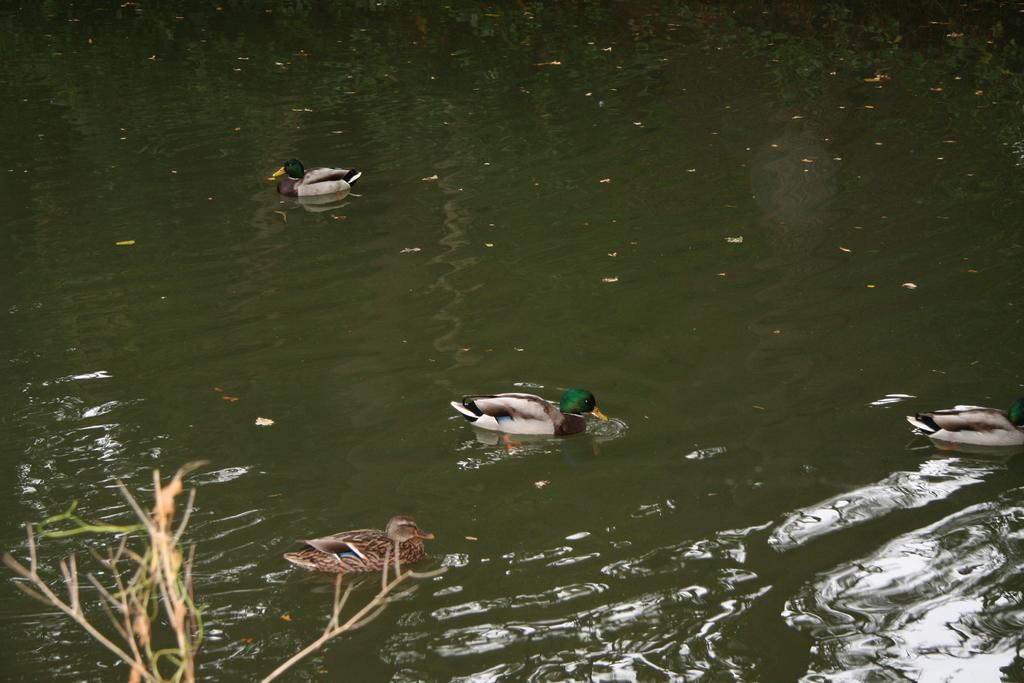What type of animals can be seen in the image? There are ducks in the water in the image. What is the primary element in which the ducks are situated? The ducks are situated in water. What can be seen in the bottom left corner of the image? There are stems visible in the bottom left corner of the image. What type of drop can be seen falling from the sky in the image? There is no drop falling from the sky in the image. 